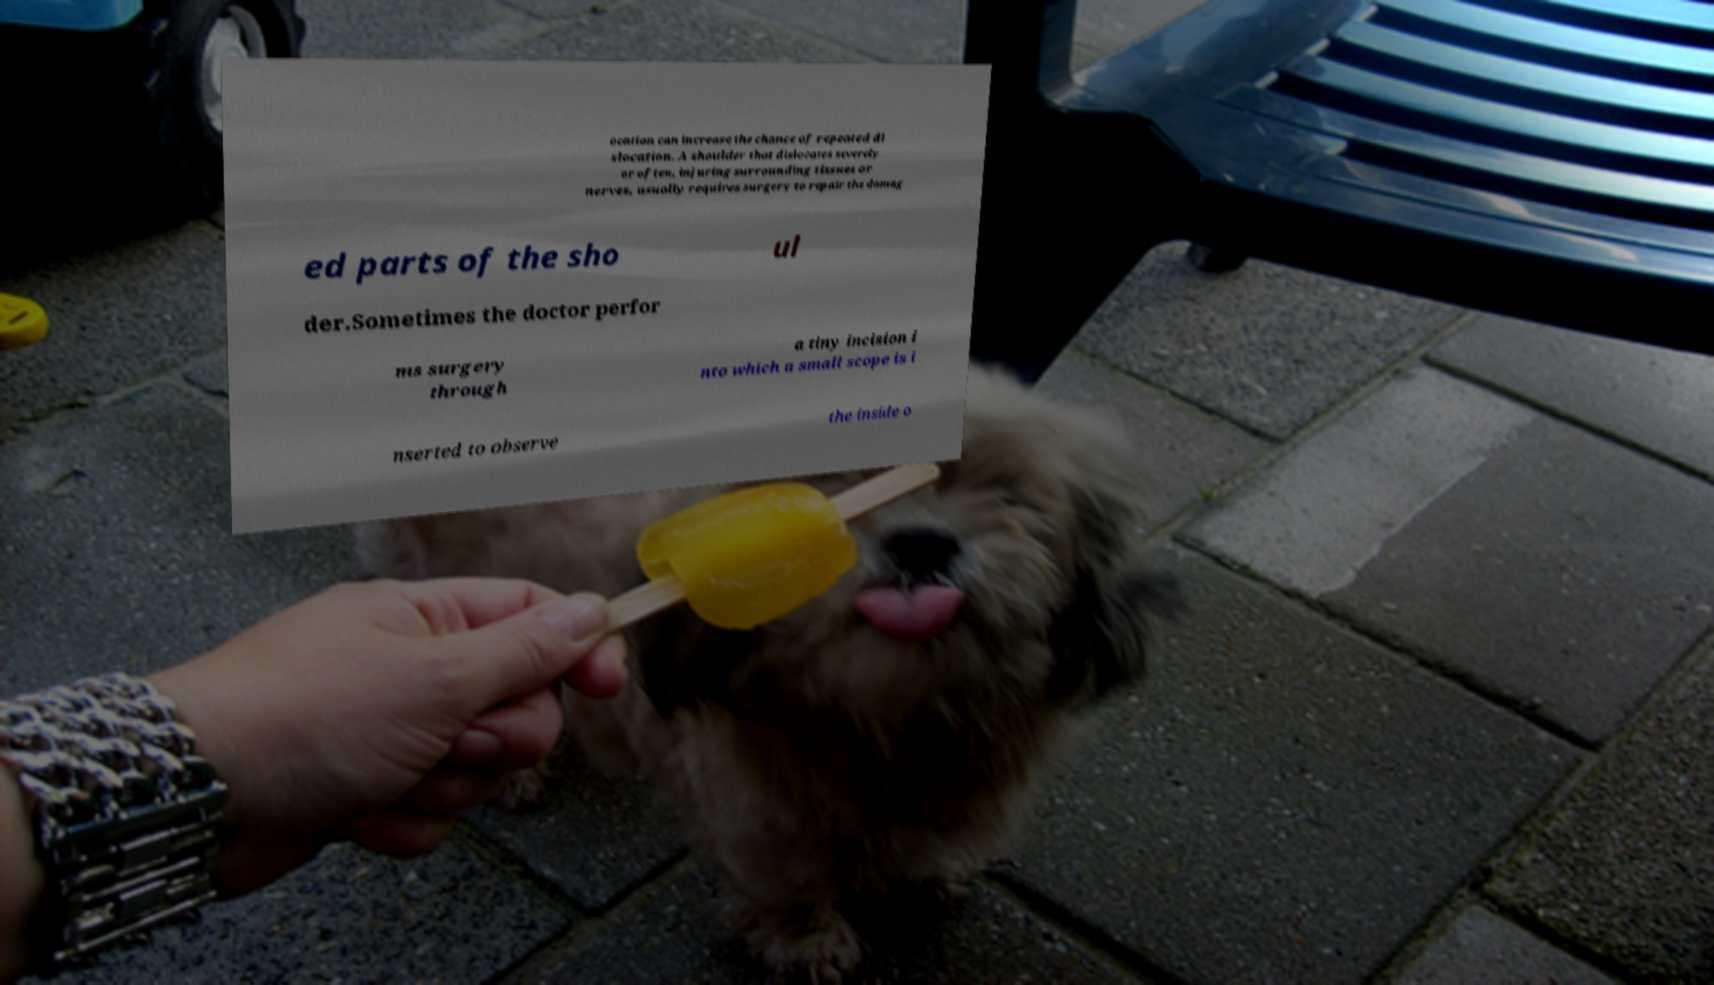Can you read and provide the text displayed in the image?This photo seems to have some interesting text. Can you extract and type it out for me? ocation can increase the chance of repeated di slocation. A shoulder that dislocates severely or often, injuring surrounding tissues or nerves, usually requires surgery to repair the damag ed parts of the sho ul der.Sometimes the doctor perfor ms surgery through a tiny incision i nto which a small scope is i nserted to observe the inside o 